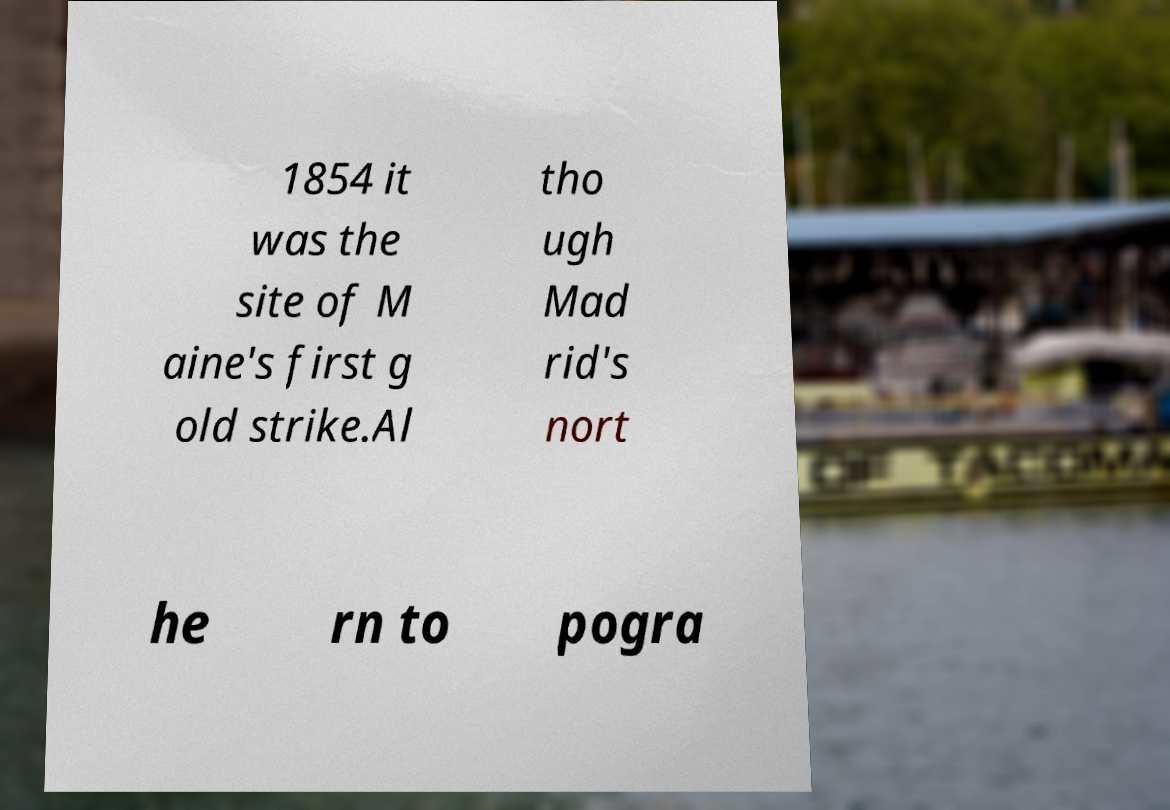Please identify and transcribe the text found in this image. 1854 it was the site of M aine's first g old strike.Al tho ugh Mad rid's nort he rn to pogra 